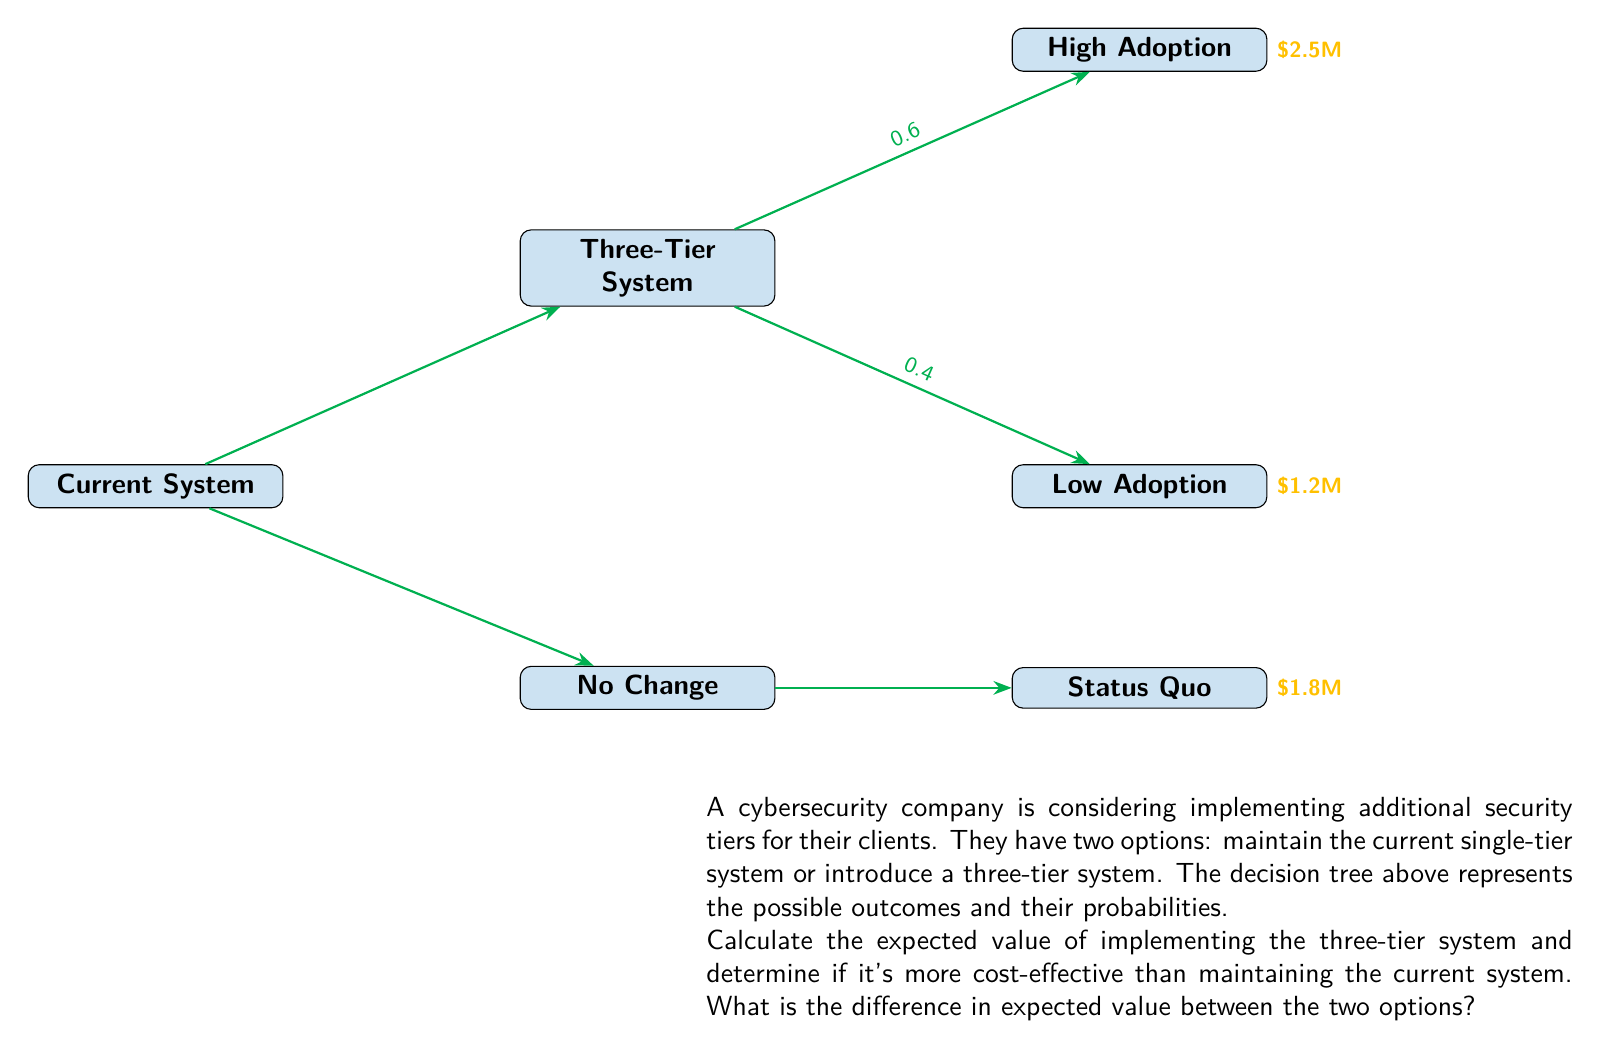Help me with this question. Let's approach this problem step-by-step using decision tree analysis:

1) First, calculate the expected value of the three-tier system:

   $$EV(\text{Three-Tier}) = 0.6 \times \$2.5M + 0.4 \times \$1.2M$$
   $$= \$1.5M + \$0.48M = \$1.98M$$

2) The expected value of maintaining the current system is simply the "Status Quo" value:

   $$EV(\text{Current}) = \$1.8M$$

3) To determine if the three-tier system is more cost-effective, we compare the two expected values:

   $$\text{Difference} = EV(\text{Three-Tier}) - EV(\text{Current})$$
   $$= \$1.98M - \$1.8M = \$0.18M$$

4) Since the difference is positive, the three-tier system is more cost-effective.

5) The difference in expected value between the two options is $0.18M or $180,000.
Answer: $180,000 